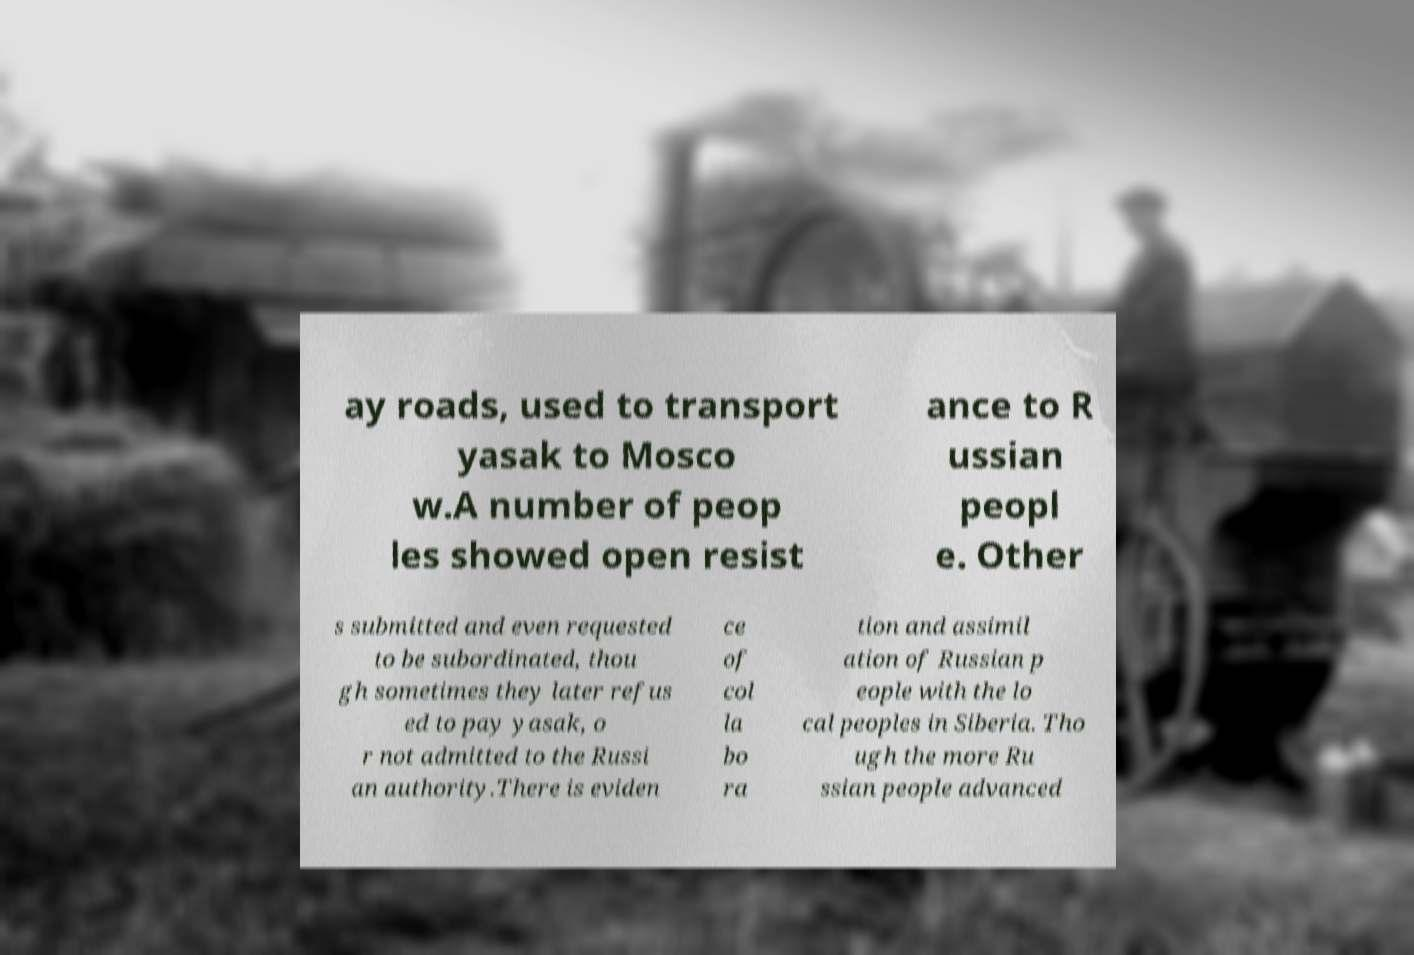Can you read and provide the text displayed in the image?This photo seems to have some interesting text. Can you extract and type it out for me? ay roads, used to transport yasak to Mosco w.A number of peop les showed open resist ance to R ussian peopl e. Other s submitted and even requested to be subordinated, thou gh sometimes they later refus ed to pay yasak, o r not admitted to the Russi an authority.There is eviden ce of col la bo ra tion and assimil ation of Russian p eople with the lo cal peoples in Siberia. Tho ugh the more Ru ssian people advanced 